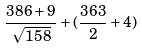Convert formula to latex. <formula><loc_0><loc_0><loc_500><loc_500>\frac { 3 8 6 + 9 } { \sqrt { 1 5 8 } } + ( \frac { 3 6 3 } { 2 } + 4 )</formula> 